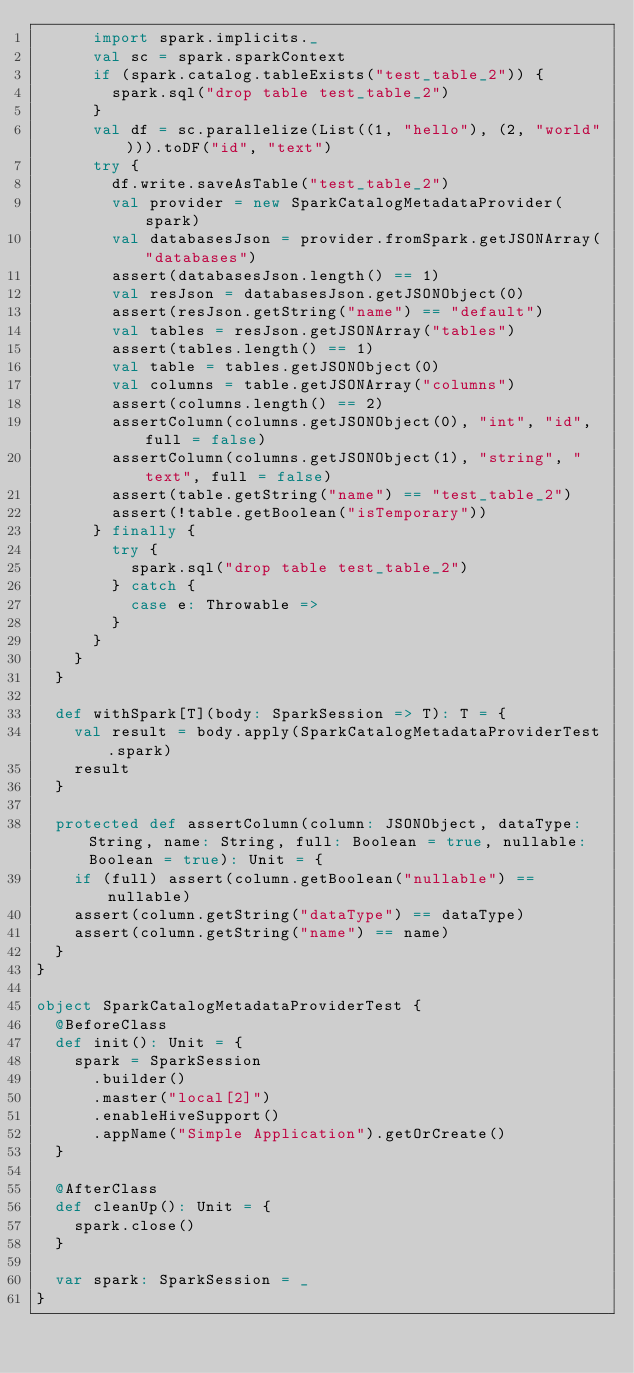<code> <loc_0><loc_0><loc_500><loc_500><_Scala_>      import spark.implicits._
      val sc = spark.sparkContext
      if (spark.catalog.tableExists("test_table_2")) {
        spark.sql("drop table test_table_2")
      }
      val df = sc.parallelize(List((1, "hello"), (2, "world"))).toDF("id", "text")
      try {
        df.write.saveAsTable("test_table_2")
        val provider = new SparkCatalogMetadataProvider(spark)
        val databasesJson = provider.fromSpark.getJSONArray("databases")
        assert(databasesJson.length() == 1)
        val resJson = databasesJson.getJSONObject(0)
        assert(resJson.getString("name") == "default")
        val tables = resJson.getJSONArray("tables")
        assert(tables.length() == 1)
        val table = tables.getJSONObject(0)
        val columns = table.getJSONArray("columns")
        assert(columns.length() == 2)
        assertColumn(columns.getJSONObject(0), "int", "id", full = false)
        assertColumn(columns.getJSONObject(1), "string", "text", full = false)
        assert(table.getString("name") == "test_table_2")
        assert(!table.getBoolean("isTemporary"))
      } finally {
        try {
          spark.sql("drop table test_table_2")
        } catch {
          case e: Throwable =>
        }
      }
    }
  }

  def withSpark[T](body: SparkSession => T): T = {
    val result = body.apply(SparkCatalogMetadataProviderTest.spark)
    result
  }

  protected def assertColumn(column: JSONObject, dataType: String, name: String, full: Boolean = true, nullable: Boolean = true): Unit = {
    if (full) assert(column.getBoolean("nullable") == nullable)
    assert(column.getString("dataType") == dataType)
    assert(column.getString("name") == name)
  }
}

object SparkCatalogMetadataProviderTest {
  @BeforeClass
  def init(): Unit = {
    spark = SparkSession
      .builder()
      .master("local[2]")
      .enableHiveSupport()
      .appName("Simple Application").getOrCreate()
  }

  @AfterClass
  def cleanUp(): Unit = {
    spark.close()
  }

  var spark: SparkSession = _
}
</code> 